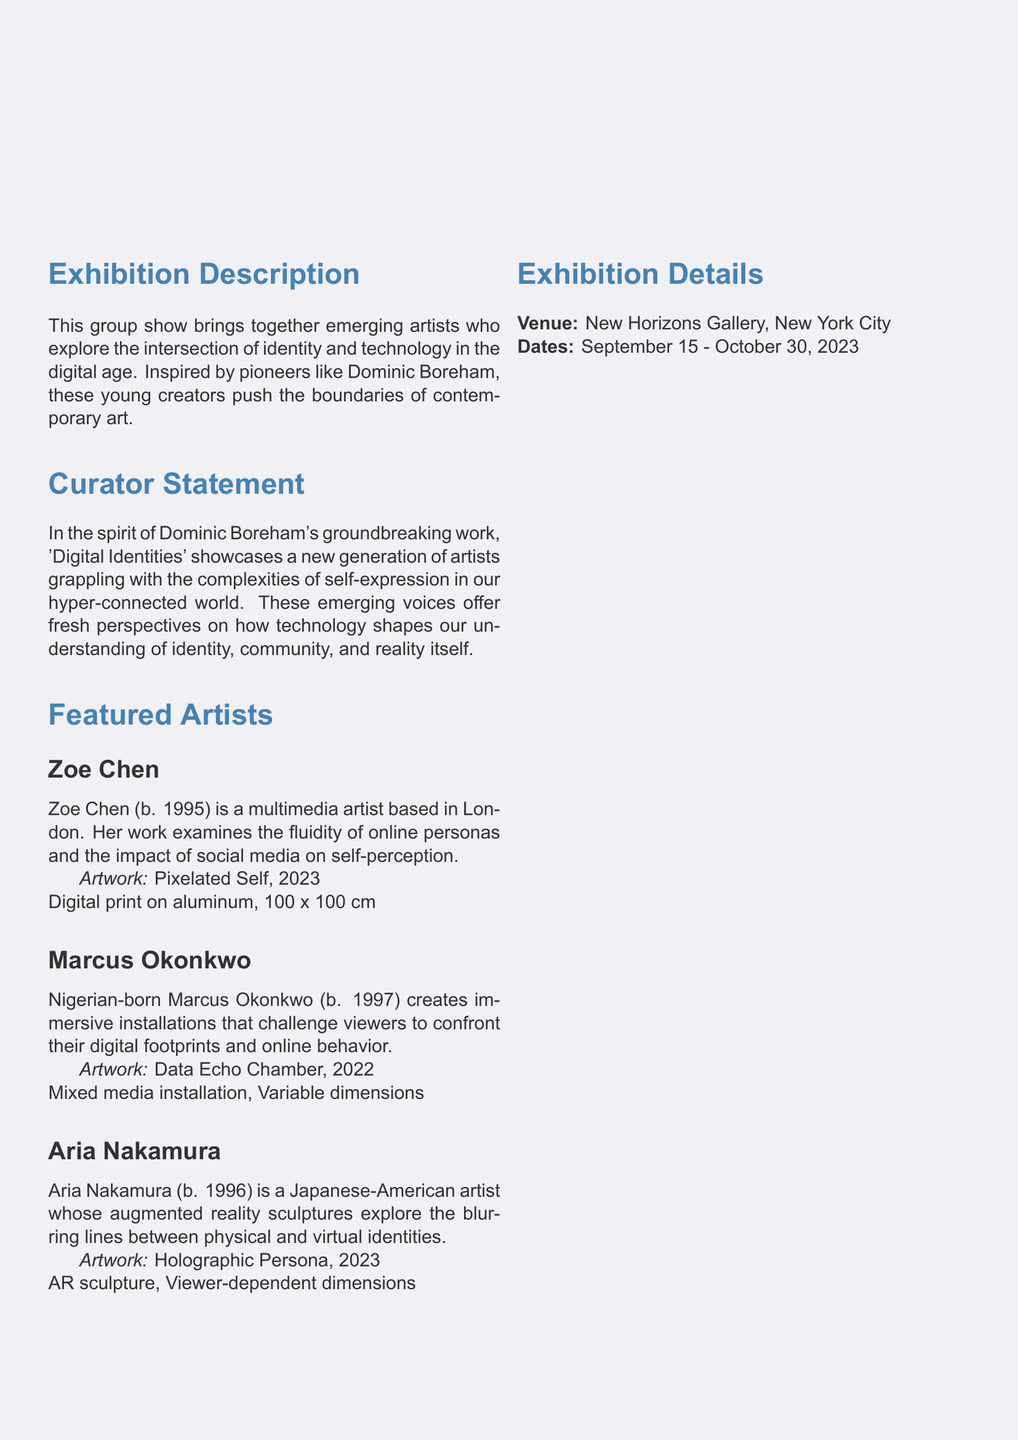What is the title of the exhibition? The title of the exhibition is prominently displayed in the header at the top of the document.
Answer: Digital Identities: The Next Generation Who is one of the featured artists? The document lists multiple featured artists under the "Featured Artists" section.
Answer: Zoe Chen What is the medium of Aria Nakamura's artwork? The medium is specified in the description of each artwork under the "Featured Artists" section.
Answer: AR sculpture What are the exhibition dates? The exhibition dates are clearly noted in the "Exhibition Details" section.
Answer: September 15 - October 30, 2023 What does Marcus Okonkwo's artwork challenge viewers to confront? This information is found in the description of Marcus Okonkwo's work under "Featured Artists."
Answer: Digital footprints Which city is the exhibition located in? The venue details are provided in the "Exhibition Details" section.
Answer: New York City What is the title of Marcus Okonkwo's artwork? The title is provided with each artist's description in the "Featured Artists" section.
Answer: Data Echo Chamber What themes do the artists in this exhibition explore? The themes are mentioned in both the exhibition description and the curator statement.
Answer: Identity and technology 